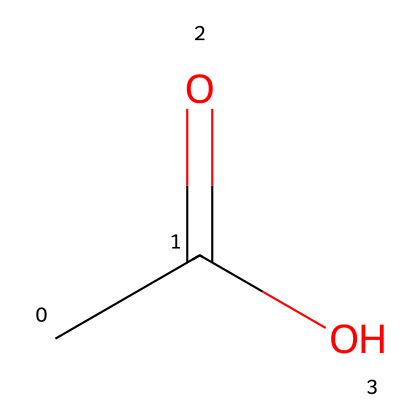What is the molecular formula of this compound? The chemical structure shows one carbon atom connected to another carbon with a double bond to oxygen, and an -OH group also connected to the first carbon. Counting the atoms, there are two carbon atoms, four hydrogen atoms, and two oxygen atoms, which gives the molecular formula C2H4O2.
Answer: C2H4O2 How many functional groups can be identified in this structure? Observing the structure, there is a carboxylic acid functional group present, characterized by the -COOH part. There are no other functional groups in this chemical, so the count is one.
Answer: 1 What type of acid is acetic acid? Acetic acid is classified as a weak acid because it only partially dissociates in water. This structure indicates it has acidic properties due to the presence of the carboxylic functional group which can donate a proton (H+).
Answer: weak acid How many hydrogen atoms are present in acetic acid? In the structure, the chemical contains four hydrogen atoms attached to the carbon atoms and the hydroxyl group (-OH). Counting these carefully shows all hydrogen atoms that contribute to the overall molecular structure.
Answer: 4 What is one primary use of acetic acid in the context of film preservation? Acetic acid is primarily used in film preservation techniques as it helps stabilize the film material over time, preventing the degradation of the emulsion and the film base. In archival storage, maintaining a proper acidity level is crucial for longevity.
Answer: stabilization 